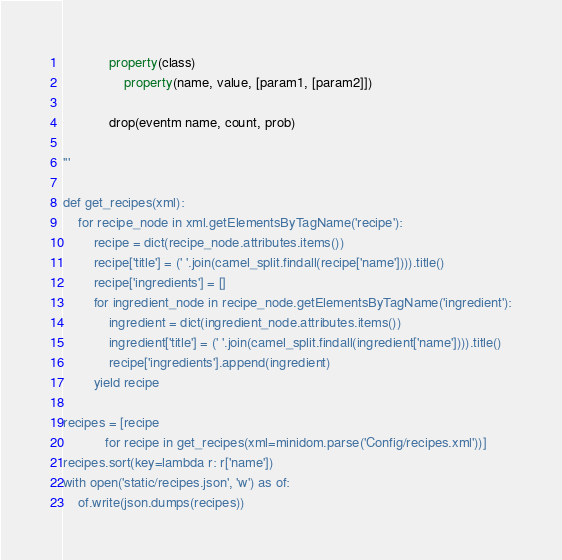<code> <loc_0><loc_0><loc_500><loc_500><_Python_>            property(class)
                property(name, value, [param1, [param2]])

            drop(eventm name, count, prob)

'''

def get_recipes(xml):
    for recipe_node in xml.getElementsByTagName('recipe'):
        recipe = dict(recipe_node.attributes.items())
        recipe['title'] = (' '.join(camel_split.findall(recipe['name']))).title()
        recipe['ingredients'] = []
        for ingredient_node in recipe_node.getElementsByTagName('ingredient'):
            ingredient = dict(ingredient_node.attributes.items())
            ingredient['title'] = (' '.join(camel_split.findall(ingredient['name']))).title()
            recipe['ingredients'].append(ingredient)
        yield recipe

recipes = [recipe
           for recipe in get_recipes(xml=minidom.parse('Config/recipes.xml'))]
recipes.sort(key=lambda r: r['name'])
with open('static/recipes.json', 'w') as of:
    of.write(json.dumps(recipes))

</code> 